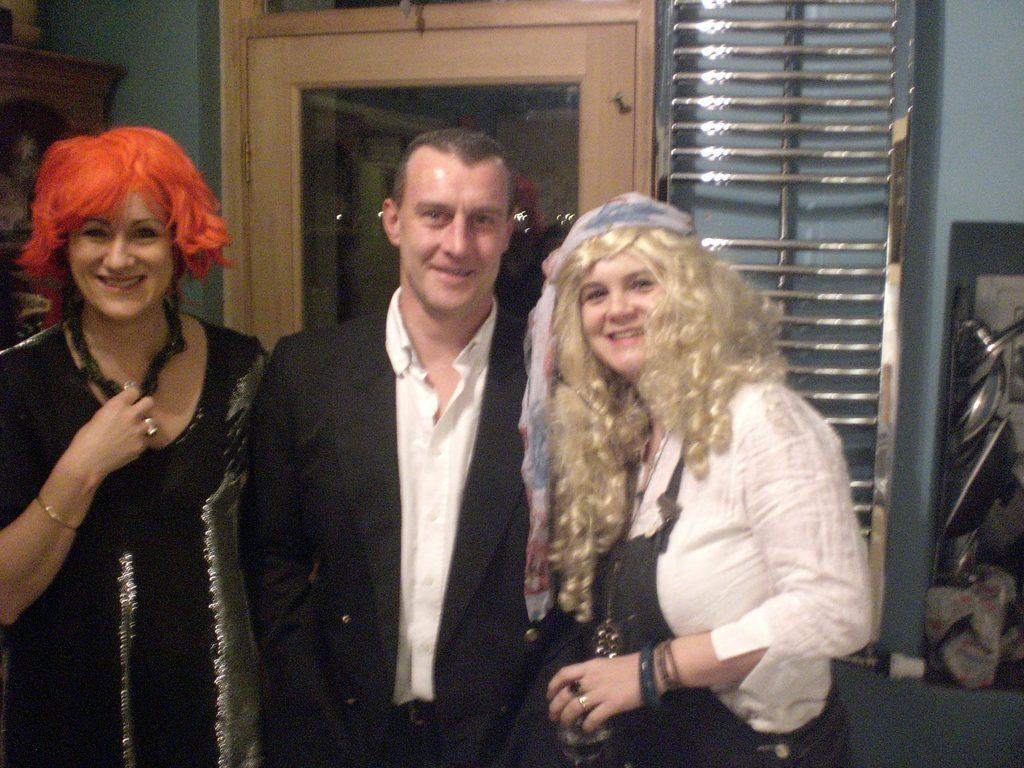Who or what is present in the image? There are people in the image. What is the facial expression of the people in the image? The people are smiling. What type of material is used for the rods visible in the image? There are metal rods visible in the image. What feature of a building can be seen in the image? There is a door in the image. What type of humor can be seen in the image? There is no specific humor depicted in the image; it simply shows people smiling. Can you tell me how many hens are present in the image? There are no hens present in the image. 